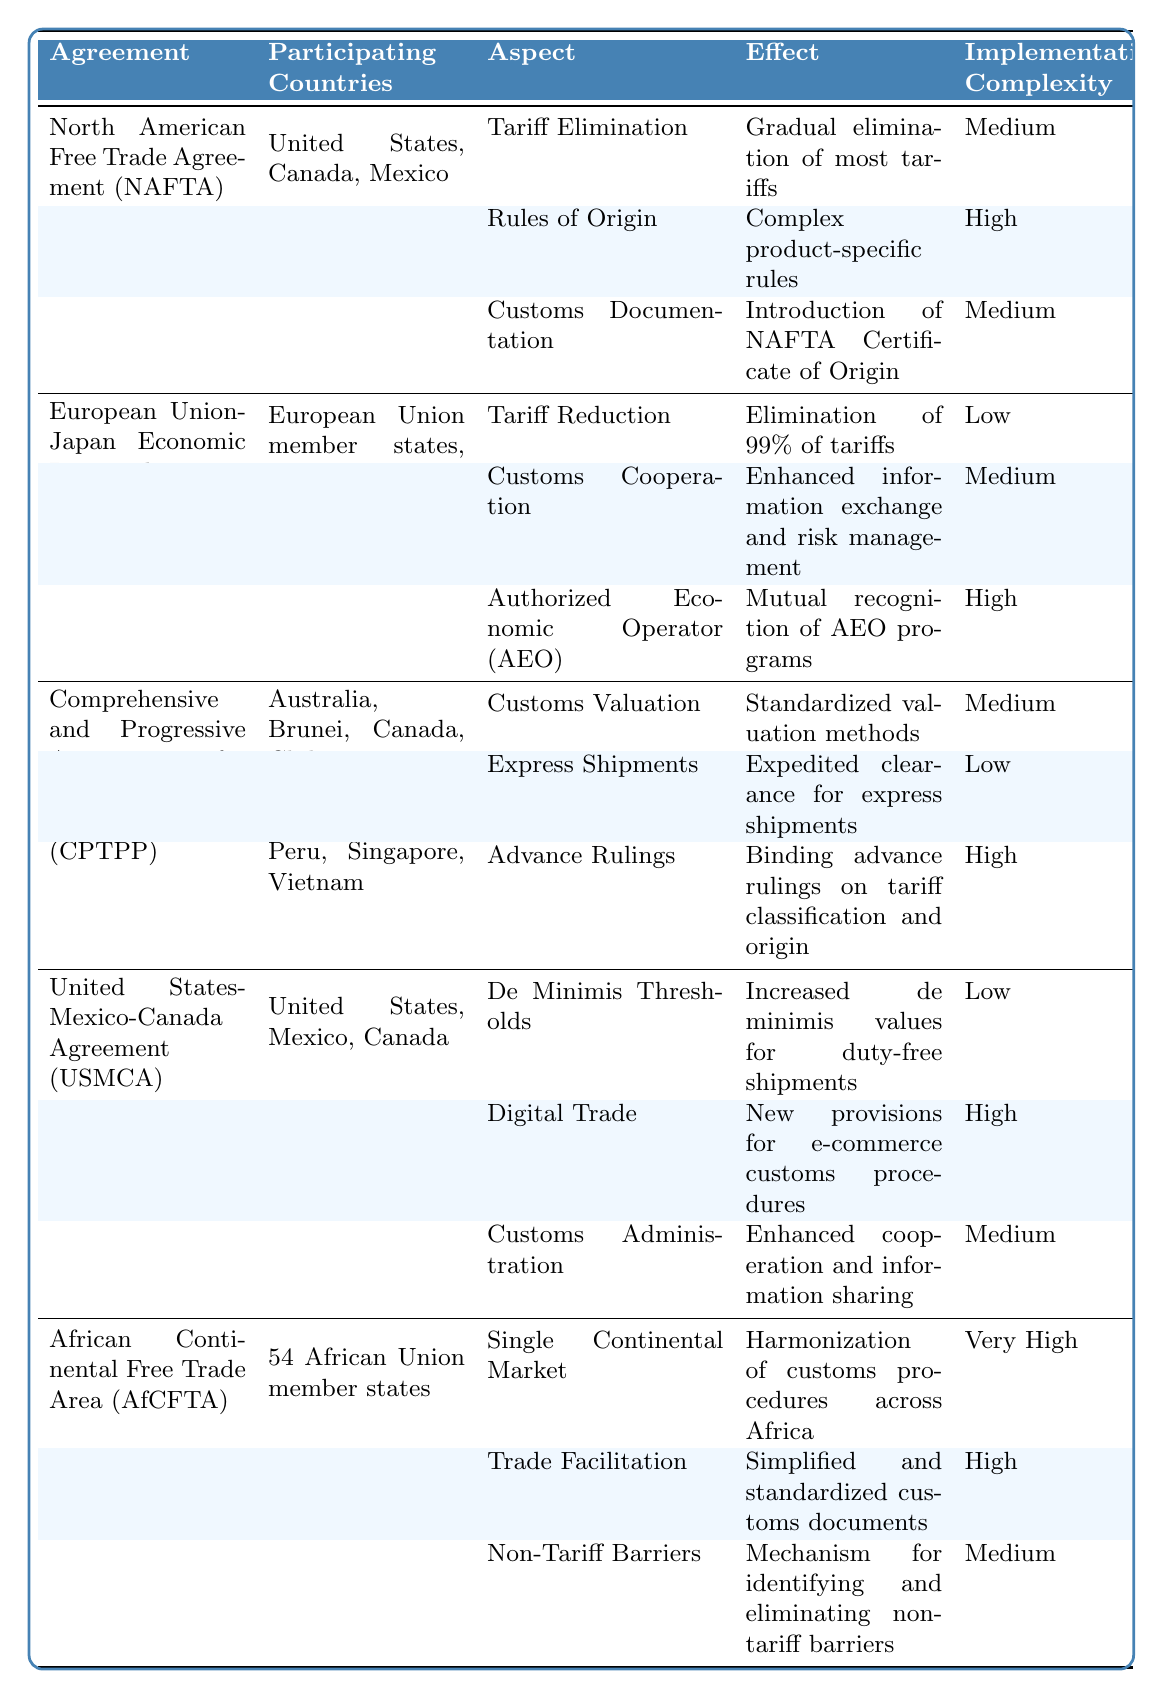What is the effect of the tariff elimination in NAFTA? The table indicates that the effect of tariff elimination under NAFTA is the gradual elimination of most tariffs. This information can be found in the row corresponding to NAFTA in the "Impact on Customs Procedures" section.
Answer: Gradual elimination of most tariffs Which agreement has the highest implementation complexity in its customs procedures? By reviewing the "Implementation Complexity" column across the agreements, I can see that the African Continental Free Trade Area (AfCFTA) has an aspect (Single Continental Market) listed as "Very High" for implementation complexity, which is higher than any other listed agreements.
Answer: African Continental Free Trade Area (AfCFTA) What is the implementation complexity of customs cooperation in the EU-Japan EPA? Looking at the EU-Japan EPA row in the table, the implementation complexity for the aspect of customs cooperation is listed as "Medium."
Answer: Medium How many aspects listed under the CPTPP have a high implementation complexity? In the CPTPP section, I see that there are three aspects: Customs Valuation (Medium), Express Shipments (Low), and Advance Rulings (High). Only the Advance Rulings aspect has a high implementation complexity. Thus, there is a count of one aspect with high complexity.
Answer: 1 Is there a customs documentation requirement specific to the USMCA? According to the USMCA section in the table, it lists Customs Administration but does not specify any distinct customs documentation requirement like the NAFTA Certificate of Origin seen in NAFTA. Therefore, this statement is false.
Answer: No What percentage of tariffs does the EU-Japan EPA eliminate? From the EU-Japan EPA section, it states that the effect of tariff reduction is the elimination of 99% of tariffs. This is a direct retrieval from the specified agreement's impact section.
Answer: 99% Are all the agreements listed in the table between countries from different continents? By analyzing the table, it can be noted that the African Continental Free Trade Area involves countries solely from Africa, while others involve countries from North America, Europe, and Asia. Hence, not all agreements are multilateral across continents.
Answer: No How does the implementation complexity of trade facilitation in AfCFTA compare to that in NAFTA? In the AfCFTA section, trade facilitation has a complexity of "High," while in the NAFTA section, there is an aspect (Customs Documentation) with a complexity of "Medium." Therefore, AfCFTA's complexity is higher than NAFTA's for the comparable aspects.
Answer: Higher What changes occurred in digital trade provisions under USMCA? The USMCA section specifies that new provisions for e-commerce customs procedures were introduced under digital trade, which implies a modification or enhancement compared to prior agreements.
Answer: New provisions for e-commerce customs procedures List the participating countries in the CPTPP. The CPTPP section clearly lists the participating countries as Australia, Brunei, Canada, Chile, Japan, Malaysia, Mexico, New Zealand, Peru, Singapore, and Vietnam. This is directly stated in the respective row.
Answer: Australia, Brunei, Canada, Chile, Japan, Malaysia, Mexico, New Zealand, Peru, Singapore, Vietnam 